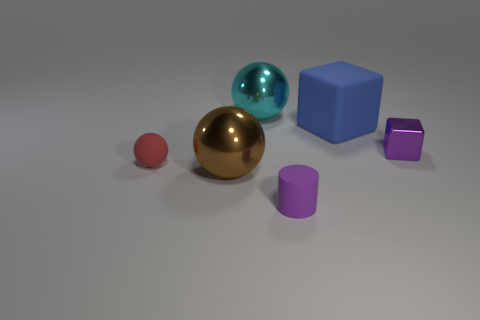Subtract all purple cubes. How many cubes are left? 1 Subtract all metallic spheres. How many spheres are left? 1 Subtract 1 cylinders. How many cylinders are left? 0 Add 5 purple cubes. How many purple cubes are left? 6 Add 5 purple rubber things. How many purple rubber things exist? 6 Add 2 large brown metal things. How many objects exist? 8 Subtract 0 purple balls. How many objects are left? 6 Subtract all cylinders. How many objects are left? 5 Subtract all blue cylinders. Subtract all green balls. How many cylinders are left? 1 Subtract all cyan cubes. How many gray balls are left? 0 